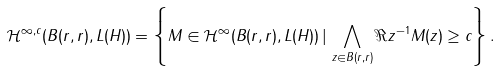Convert formula to latex. <formula><loc_0><loc_0><loc_500><loc_500>\mathcal { H } ^ { \infty , c } ( B ( r , r ) , L ( H ) ) = \left \{ M \in \mathcal { H } ^ { \infty } ( B ( r , r ) , L ( H ) ) \, | \, \bigwedge _ { z \in B ( r , r ) } \Re z ^ { - 1 } M ( z ) \geq c \right \} .</formula> 